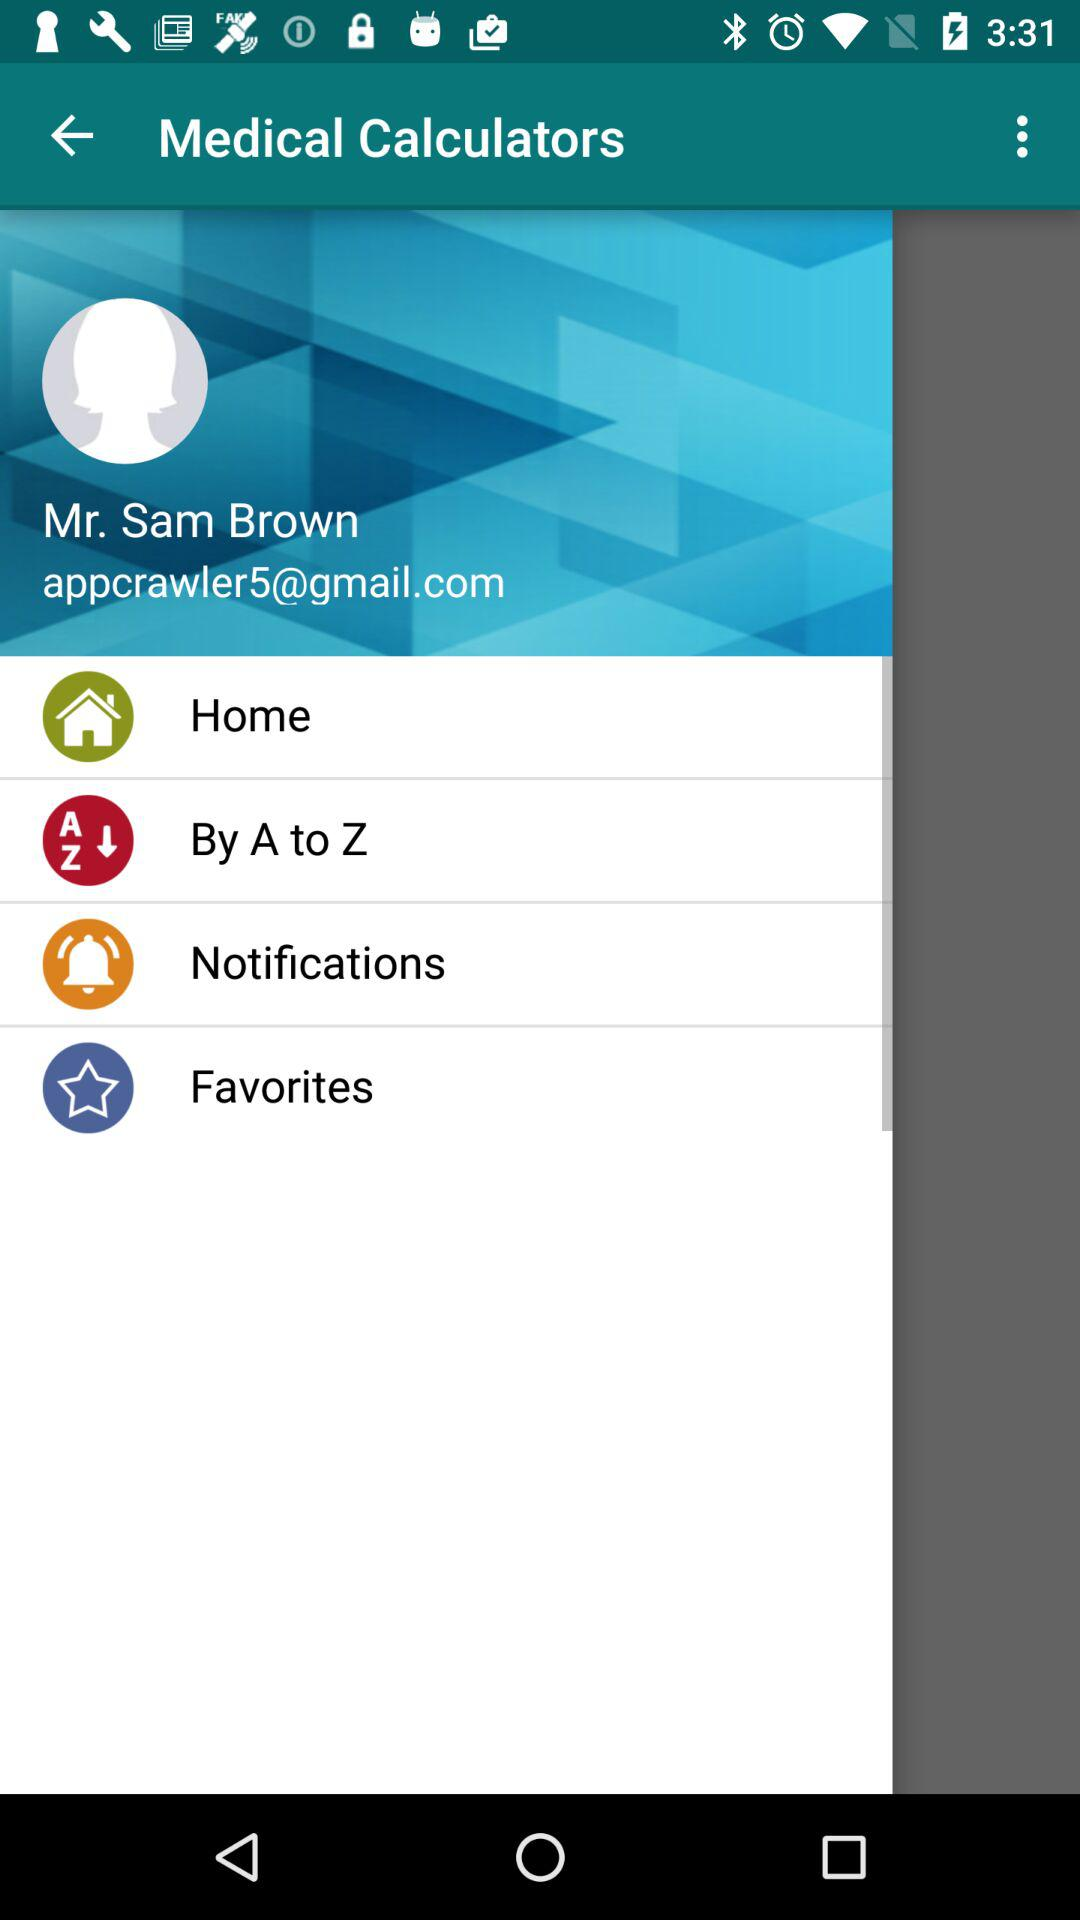What is the email address? The email address is appcrawler5@gmail.com. 